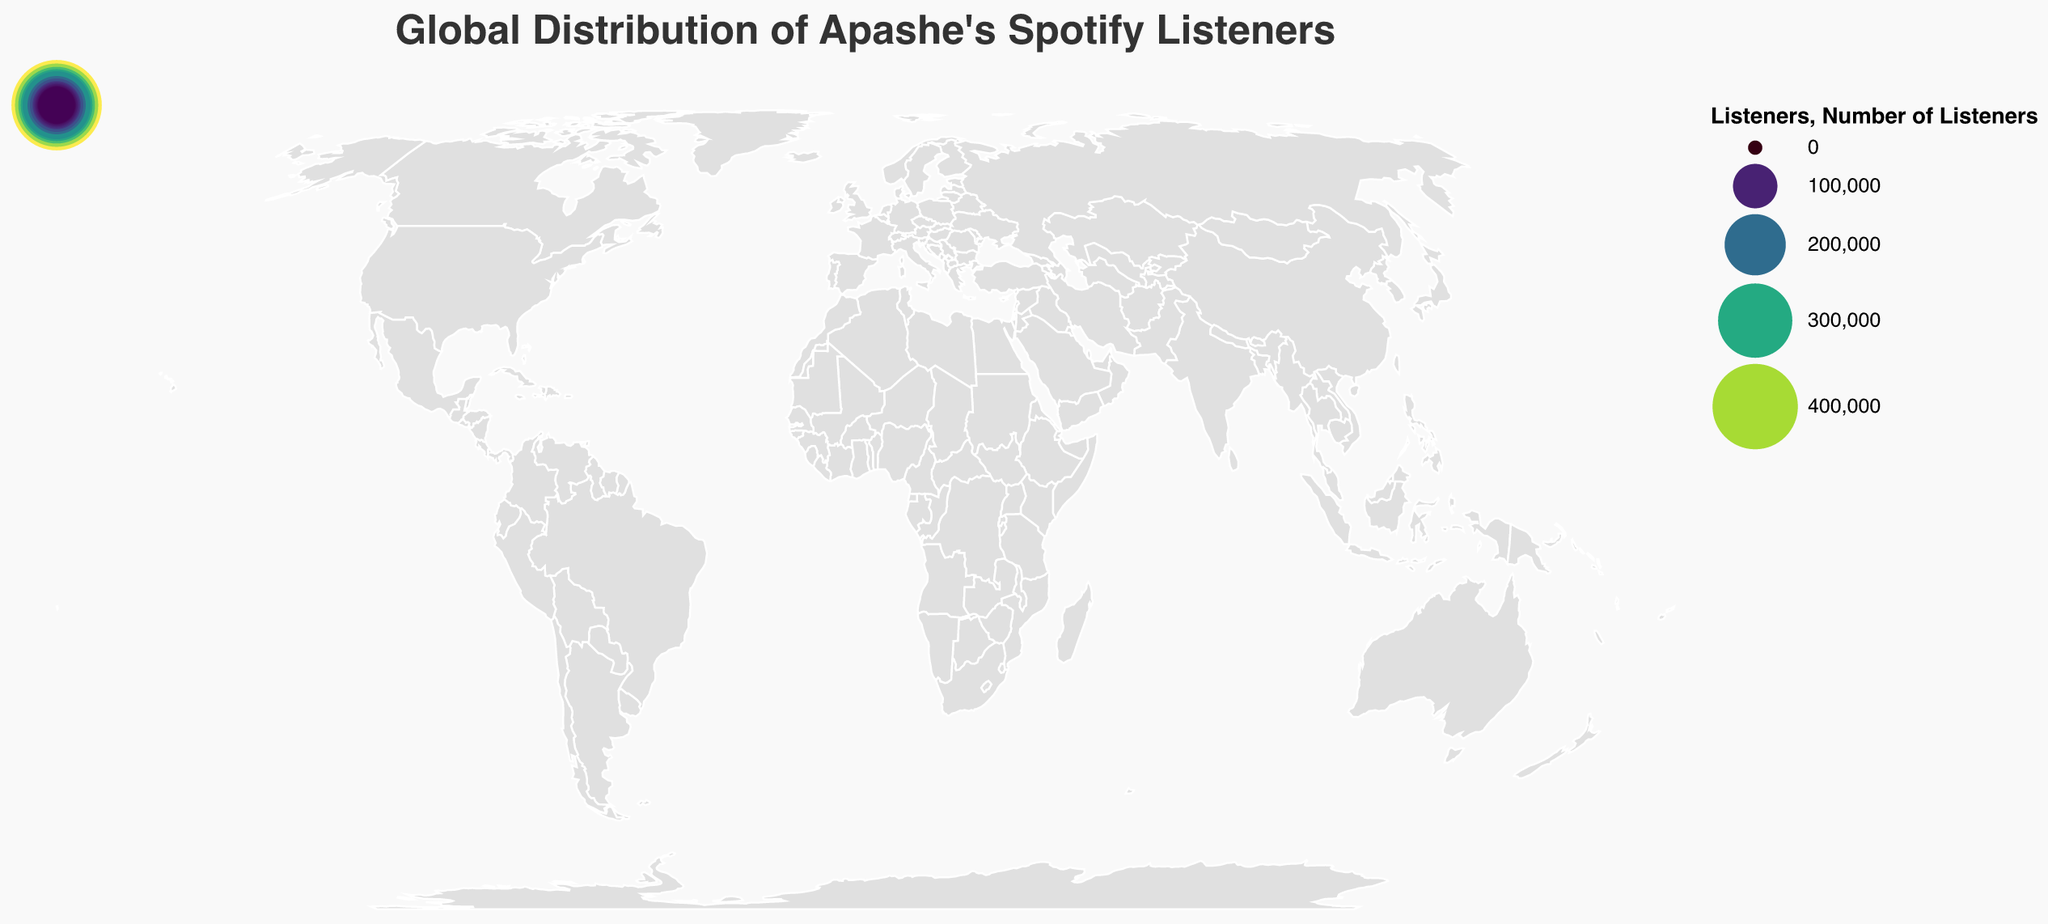How many countries are included in the figure showing Apashe's Spotify listeners? The figure includes data points for each country where Apashe has listeners. By counting the countries listed, we see there are 15.
Answer: 15 Which country has the largest number of Apashe's Spotify listeners? According to the data, the country with the largest number of listeners is the one with the highest value. The United States has 450,000 listeners, which is the highest number in the dataset.
Answer: United States What is the total number of Apashe's Spotify listeners in Europe? To determine this, add the number of listeners in European countries: France (380,000), Germany (280,000), United Kingdom (250,000), Netherlands (180,000), Belgium (150,000), Russia (100,000), Spain (90,000), Italy (85,000), Sweden (75,000), Poland (70,000). The sum is 1,580,000.
Answer: 1,580,000 What is the difference in the number of listeners between France and Brazil? The number of listeners in France is 380,000, and in Brazil, it is 110,000. The difference is 380,000 - 110,000.
Answer: 270,000 Which two countries have the closest number of Apashe's Spotify listeners? By examining the dataset, the United Kingdom (250,000) and Germany (280,000) have the smallest difference. The difference is 30,000.
Answer: United Kingdom and Germany Among the listed countries, which has the lowest number of listeners and how many do they have? By identifying the smallest number in the dataset, we see that Mexico has the lowest number of listeners, with 65,000.
Answer: Mexico, 65,000 What is the average number of listeners per country for Apashe? To find the average, sum the listeners from all countries and divide by the total number of countries. The sum is 2,680,000, and there are 15 countries. So, 2,680,000 / 15.
Answer: 178,667 Which country outside of Europe has the highest number of Apashe's Spotify listeners? By eliminating European countries and comparing the remaining numbers, the United States has the highest with 450,000 listeners.
Answer: United States How many more listeners does Canada have compared to Australia? Canada has 320,000 listeners, and Australia has 120,000. The difference is 320,000 - 120,000.
Answer: 200,000 